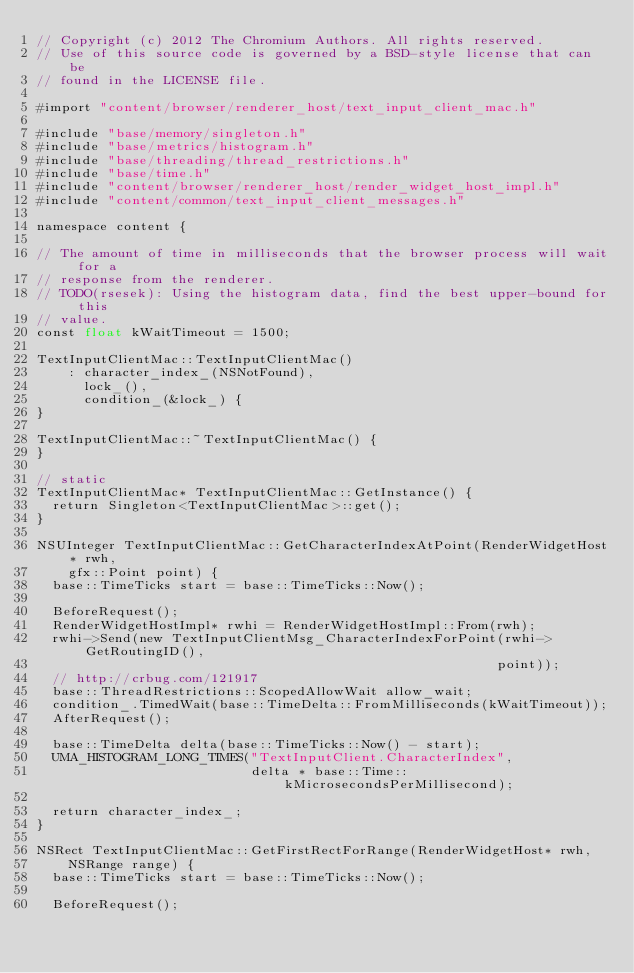Convert code to text. <code><loc_0><loc_0><loc_500><loc_500><_ObjectiveC_>// Copyright (c) 2012 The Chromium Authors. All rights reserved.
// Use of this source code is governed by a BSD-style license that can be
// found in the LICENSE file.

#import "content/browser/renderer_host/text_input_client_mac.h"

#include "base/memory/singleton.h"
#include "base/metrics/histogram.h"
#include "base/threading/thread_restrictions.h"
#include "base/time.h"
#include "content/browser/renderer_host/render_widget_host_impl.h"
#include "content/common/text_input_client_messages.h"

namespace content {

// The amount of time in milliseconds that the browser process will wait for a
// response from the renderer.
// TODO(rsesek): Using the histogram data, find the best upper-bound for this
// value.
const float kWaitTimeout = 1500;

TextInputClientMac::TextInputClientMac()
    : character_index_(NSNotFound),
      lock_(),
      condition_(&lock_) {
}

TextInputClientMac::~TextInputClientMac() {
}

// static
TextInputClientMac* TextInputClientMac::GetInstance() {
  return Singleton<TextInputClientMac>::get();
}

NSUInteger TextInputClientMac::GetCharacterIndexAtPoint(RenderWidgetHost* rwh,
    gfx::Point point) {
  base::TimeTicks start = base::TimeTicks::Now();

  BeforeRequest();
  RenderWidgetHostImpl* rwhi = RenderWidgetHostImpl::From(rwh);
  rwhi->Send(new TextInputClientMsg_CharacterIndexForPoint(rwhi->GetRoutingID(),
                                                          point));
  // http://crbug.com/121917
  base::ThreadRestrictions::ScopedAllowWait allow_wait;
  condition_.TimedWait(base::TimeDelta::FromMilliseconds(kWaitTimeout));
  AfterRequest();

  base::TimeDelta delta(base::TimeTicks::Now() - start);
  UMA_HISTOGRAM_LONG_TIMES("TextInputClient.CharacterIndex",
                           delta * base::Time::kMicrosecondsPerMillisecond);

  return character_index_;
}

NSRect TextInputClientMac::GetFirstRectForRange(RenderWidgetHost* rwh,
    NSRange range) {
  base::TimeTicks start = base::TimeTicks::Now();

  BeforeRequest();</code> 